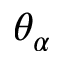<formula> <loc_0><loc_0><loc_500><loc_500>\theta _ { \alpha }</formula> 